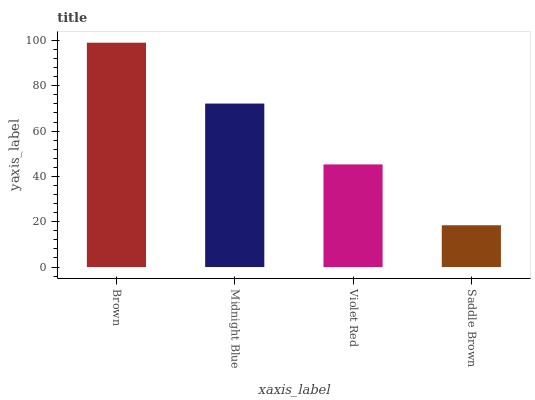Is Saddle Brown the minimum?
Answer yes or no. Yes. Is Brown the maximum?
Answer yes or no. Yes. Is Midnight Blue the minimum?
Answer yes or no. No. Is Midnight Blue the maximum?
Answer yes or no. No. Is Brown greater than Midnight Blue?
Answer yes or no. Yes. Is Midnight Blue less than Brown?
Answer yes or no. Yes. Is Midnight Blue greater than Brown?
Answer yes or no. No. Is Brown less than Midnight Blue?
Answer yes or no. No. Is Midnight Blue the high median?
Answer yes or no. Yes. Is Violet Red the low median?
Answer yes or no. Yes. Is Saddle Brown the high median?
Answer yes or no. No. Is Saddle Brown the low median?
Answer yes or no. No. 